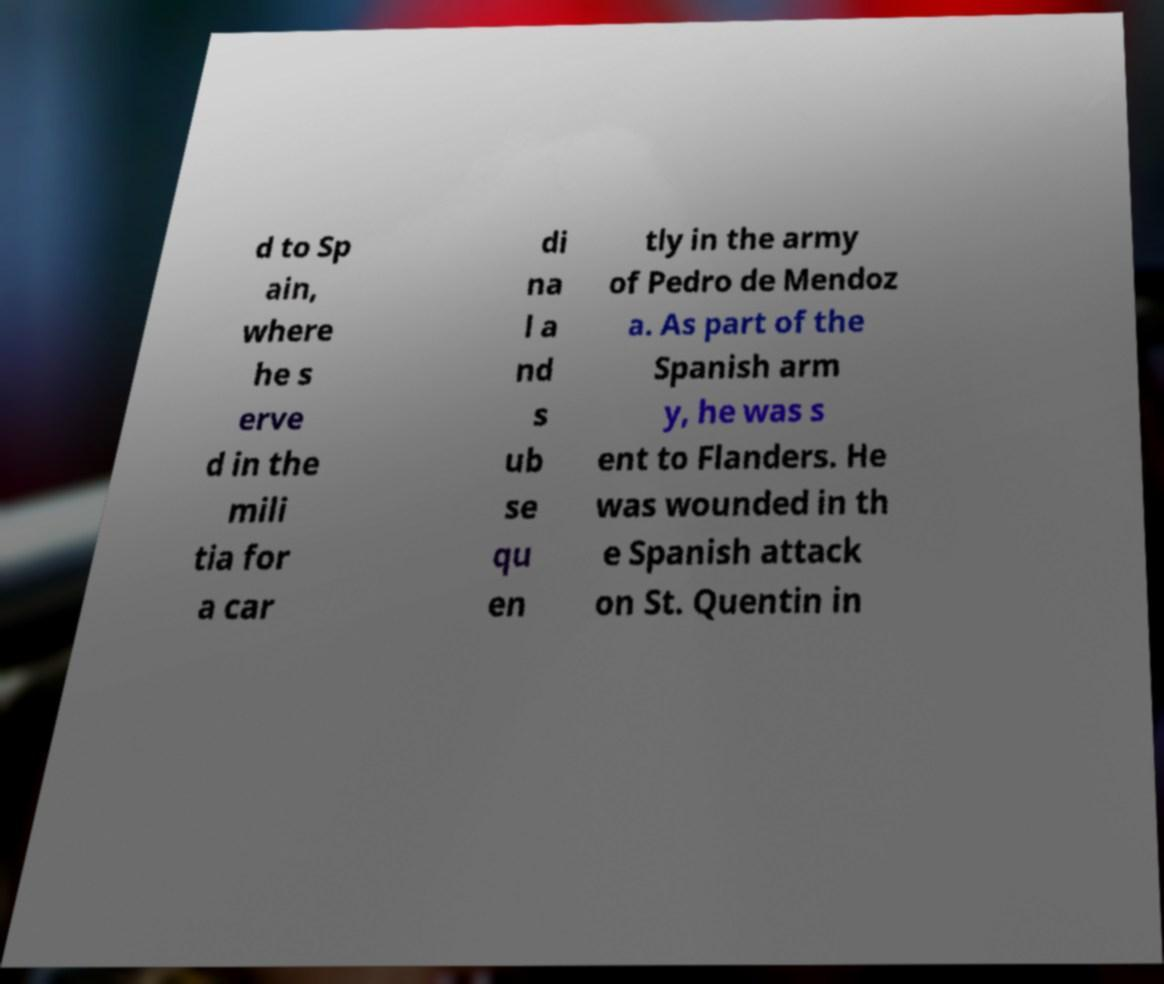Can you accurately transcribe the text from the provided image for me? d to Sp ain, where he s erve d in the mili tia for a car di na l a nd s ub se qu en tly in the army of Pedro de Mendoz a. As part of the Spanish arm y, he was s ent to Flanders. He was wounded in th e Spanish attack on St. Quentin in 